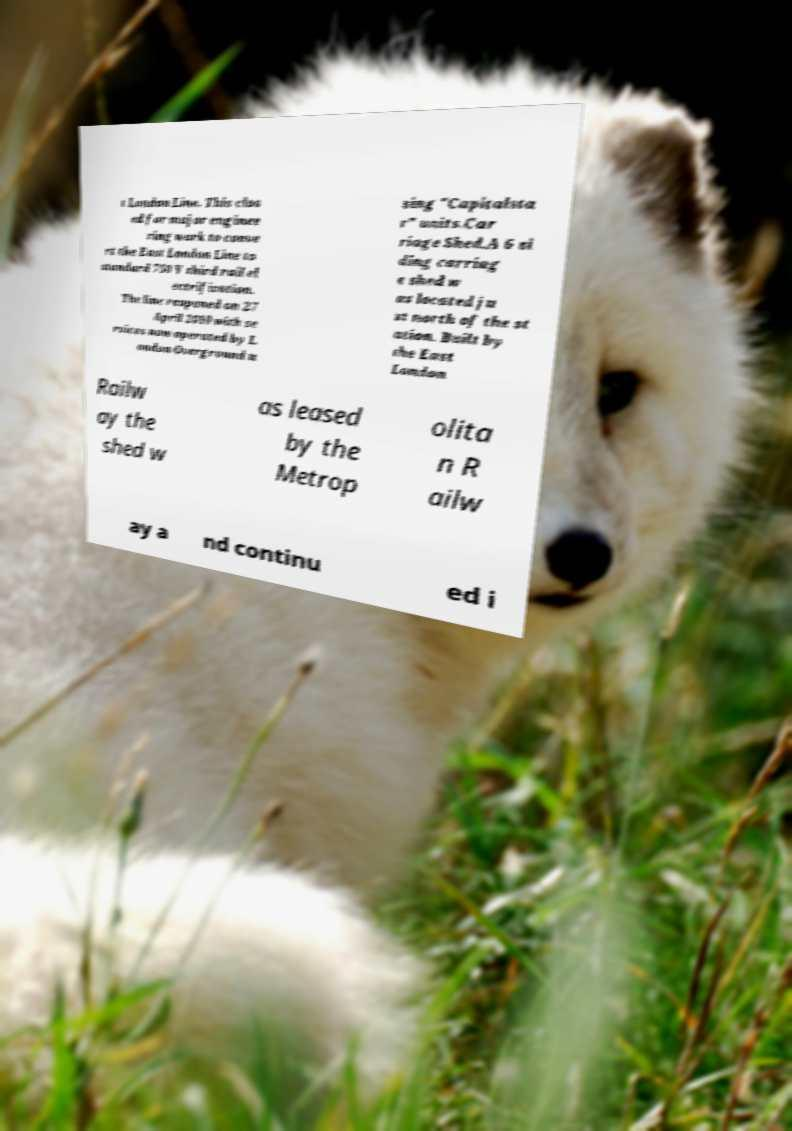Please read and relay the text visible in this image. What does it say? t London Line. This clos ed for major enginee ring work to conve rt the East London Line to standard 750 V third rail el ectrification. The line reopened on 27 April 2010 with se rvices now operated by L ondon Overground u sing "Capitalsta r" units.Car riage Shed.A 6 si ding carriag e shed w as located ju st north of the st ation. Built by the East London Railw ay the shed w as leased by the Metrop olita n R ailw ay a nd continu ed i 